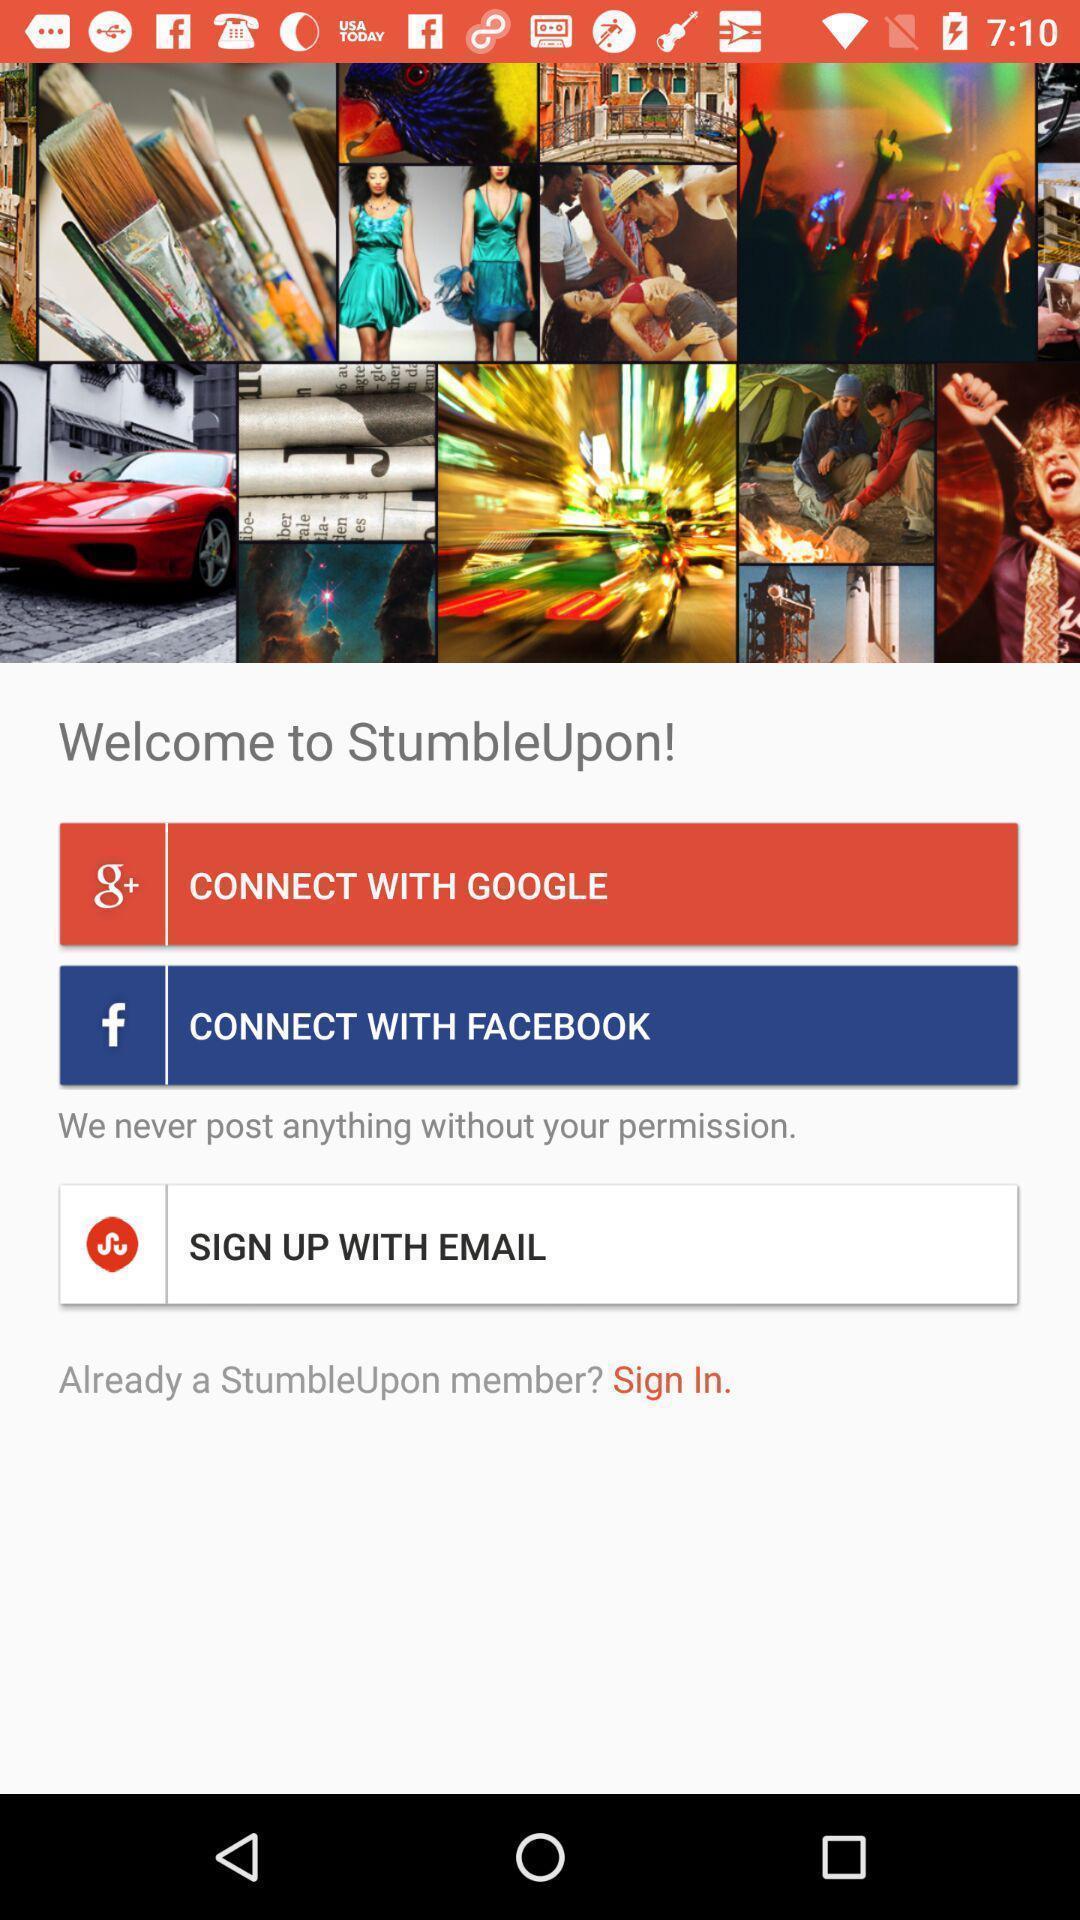Describe this image in words. Welcome page. 